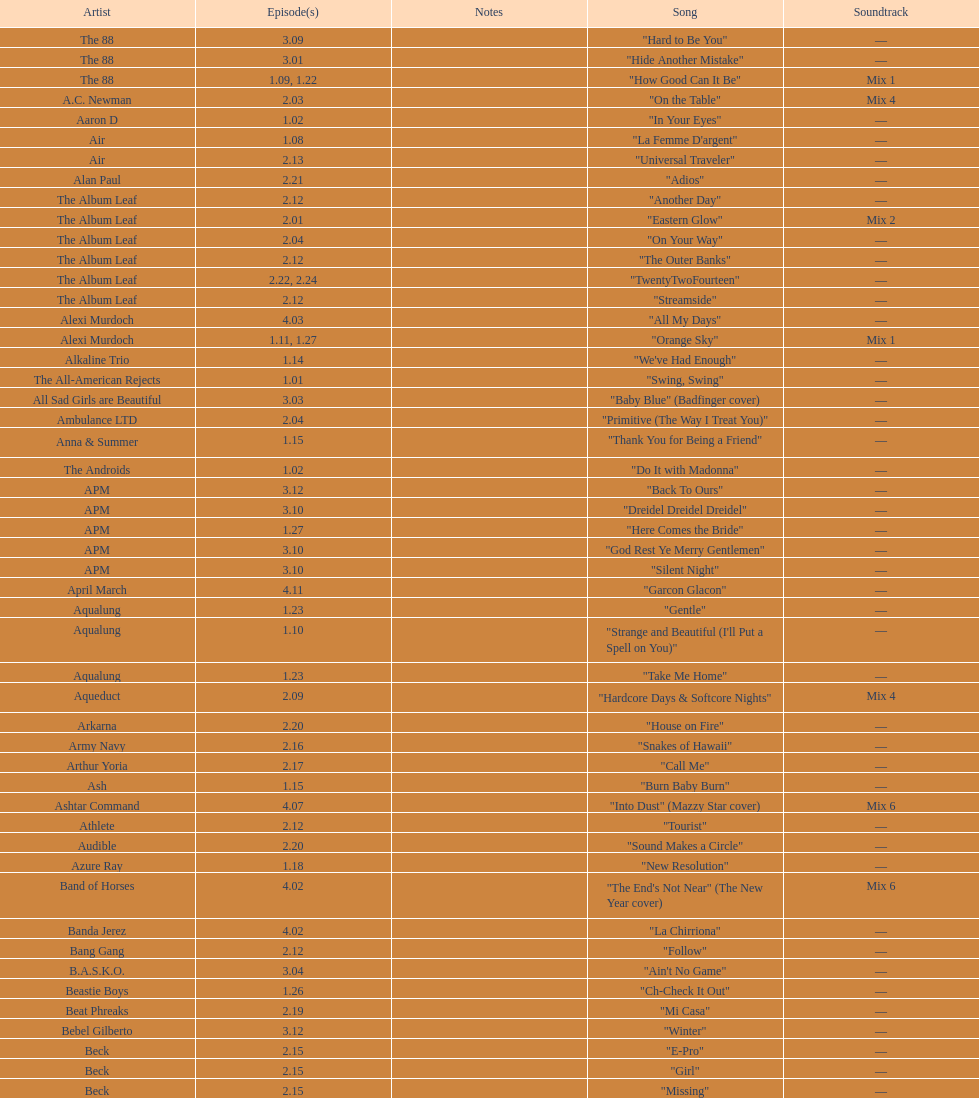How many consecutive songs were by the album leaf? 6. 